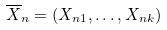<formula> <loc_0><loc_0><loc_500><loc_500>\overline { X } _ { n } = ( X _ { n 1 } , \dots , X _ { n k } )</formula> 